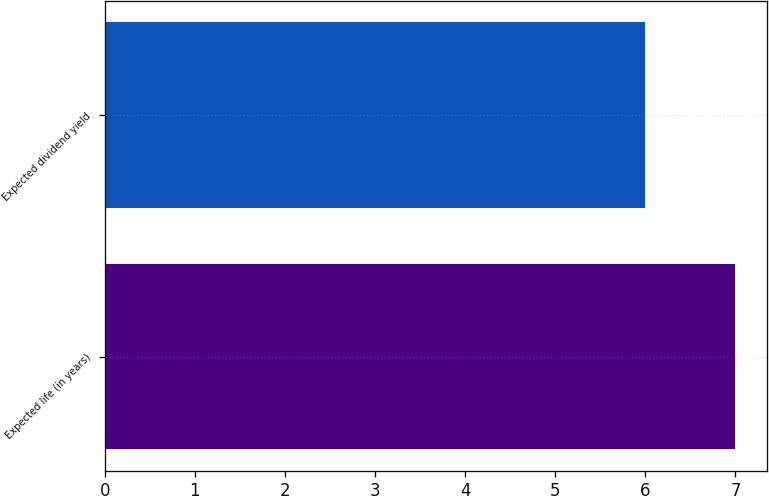Convert chart to OTSL. <chart><loc_0><loc_0><loc_500><loc_500><bar_chart><fcel>Expected life (in years)<fcel>Expected dividend yield<nl><fcel>7<fcel>6<nl></chart> 